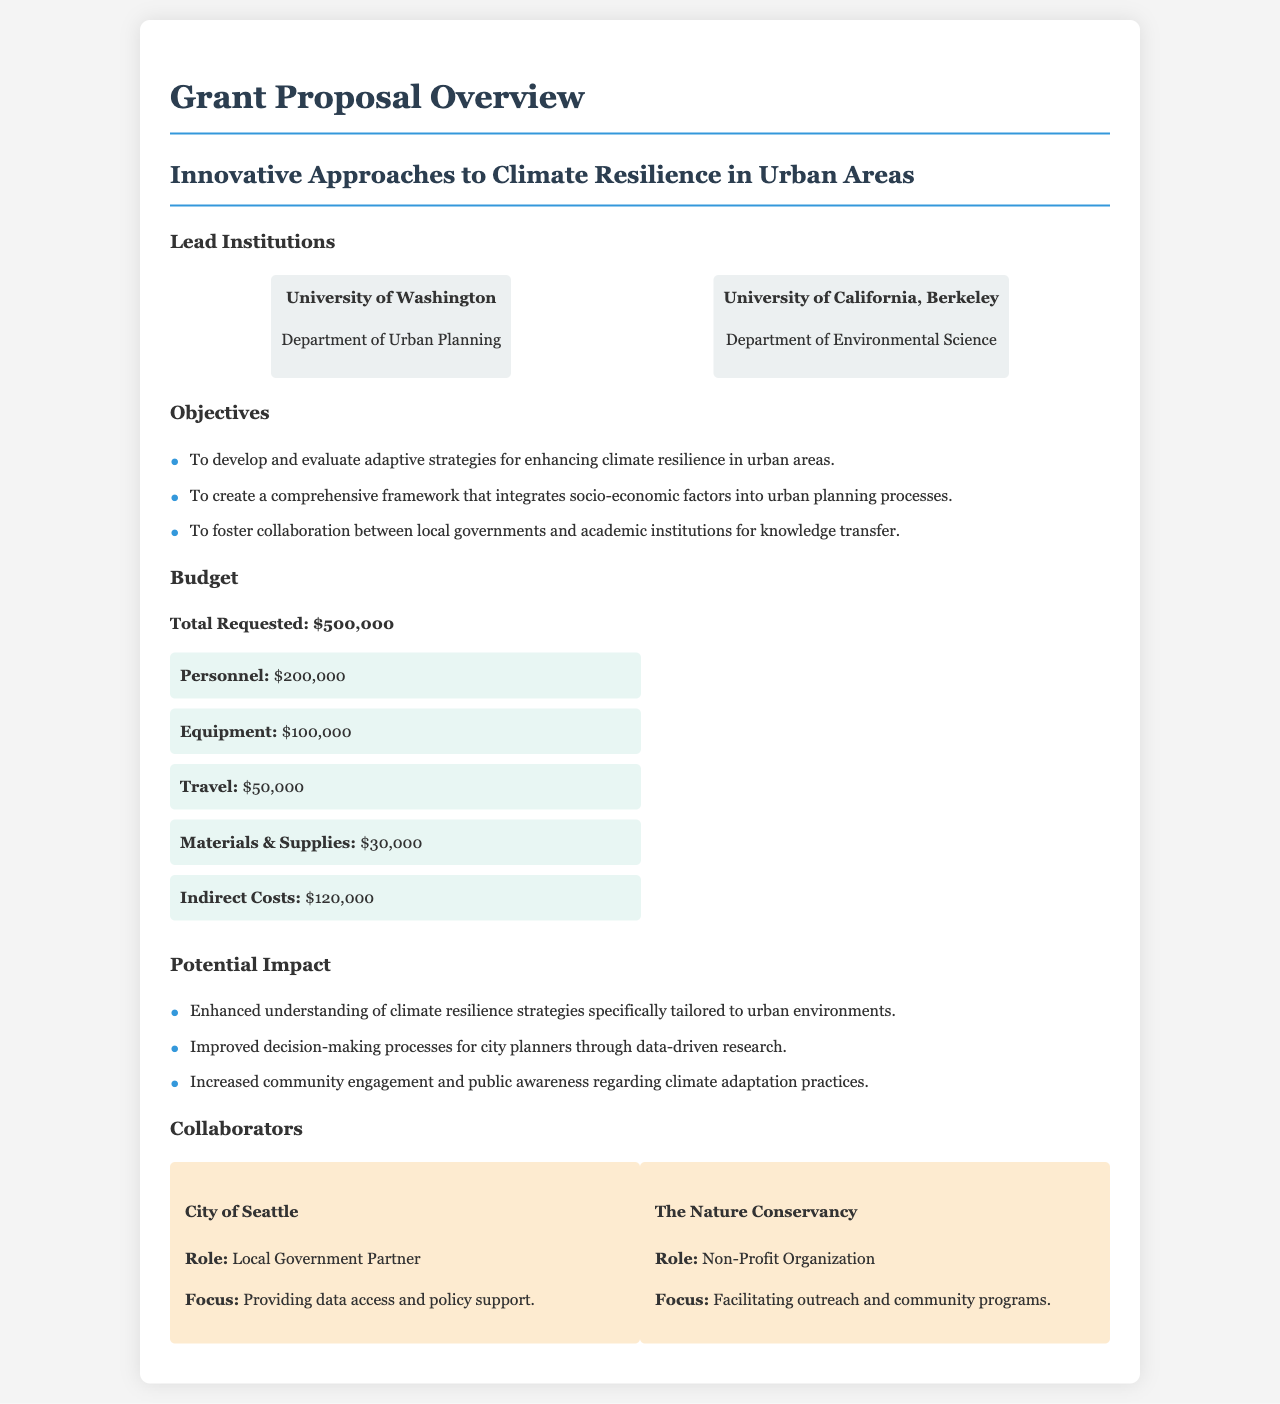What are the lead institutions? The lead institutions are listed in the document, specifically the University of Washington and the University of California, Berkeley.
Answer: University of Washington, University of California, Berkeley What is the total requested budget? The total requested budget is a key piece of financial information in the document, stated explicitly.
Answer: $500,000 How much is allocated for personnel? The document specifies the budget breakdown, including the amount designated for personnel costs.
Answer: $200,000 What is one objective of the research project? The document outlines several objectives, asking for specific information, one of which can be directly referenced.
Answer: To develop and evaluate adaptive strategies for enhancing climate resilience in urban areas Which city is a collaborator in the project? The document mentions specific collaborators, one of which is a city, and the question focuses on retrieving that detail.
Answer: City of Seattle What role does The Nature Conservancy play? The Nature Conservancy's role in the collaboration is explicitly stated in the document, making it a straightforward retrieval question.
Answer: Non-Profit Organization How much is allocated for travel in the budget? The budget section of the document lists specific amounts for various expenses, including travel.
Answer: $50,000 What type of community engagement is expected from this project? The document describes the expected impact, particularly in terms of community awareness and engagement regarding climate practices.
Answer: Increased community engagement and public awareness regarding climate adaptation practices 